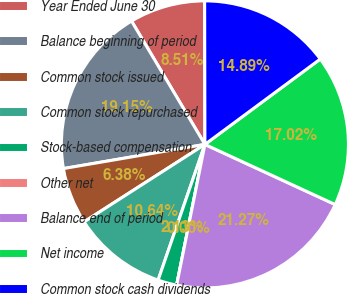Convert chart. <chart><loc_0><loc_0><loc_500><loc_500><pie_chart><fcel>Year Ended June 30<fcel>Balance beginning of period<fcel>Common stock issued<fcel>Common stock repurchased<fcel>Stock-based compensation<fcel>Other net<fcel>Balance end of period<fcel>Net income<fcel>Common stock cash dividends<nl><fcel>8.51%<fcel>19.15%<fcel>6.38%<fcel>10.64%<fcel>2.13%<fcel>0.0%<fcel>21.27%<fcel>17.02%<fcel>14.89%<nl></chart> 